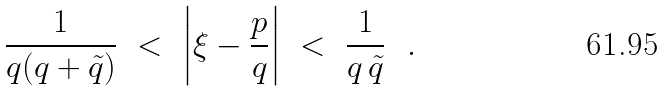Convert formula to latex. <formula><loc_0><loc_0><loc_500><loc_500>\frac { 1 } { q ( q + \tilde { q } ) } \ < \ \left | \xi - \frac { p } { q } \right | \ < \ \frac { 1 } { q \, \tilde { q } } \ \ .</formula> 